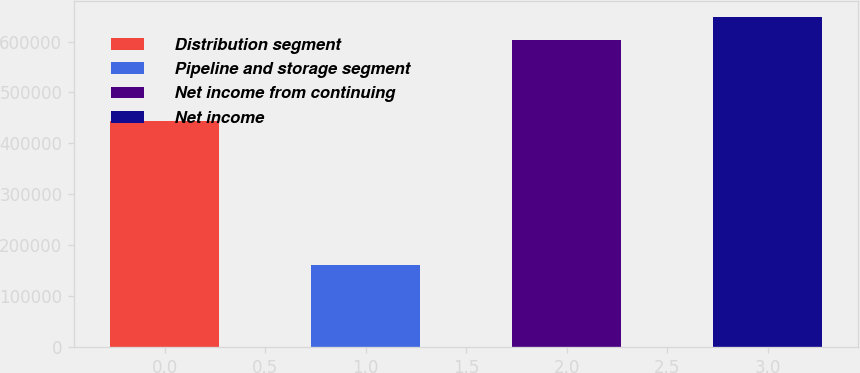Convert chart to OTSL. <chart><loc_0><loc_0><loc_500><loc_500><bar_chart><fcel>Distribution segment<fcel>Pipeline and storage segment<fcel>Net income from continuing<fcel>Net income<nl><fcel>442966<fcel>160098<fcel>603064<fcel>647361<nl></chart> 